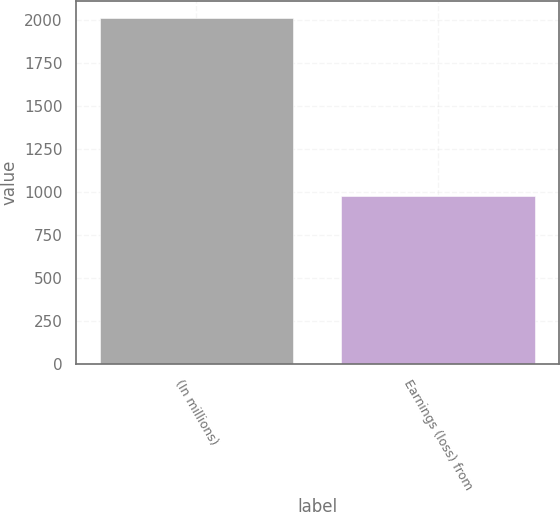Convert chart. <chart><loc_0><loc_0><loc_500><loc_500><bar_chart><fcel>(In millions)<fcel>Earnings (loss) from<nl><fcel>2010<fcel>979<nl></chart> 